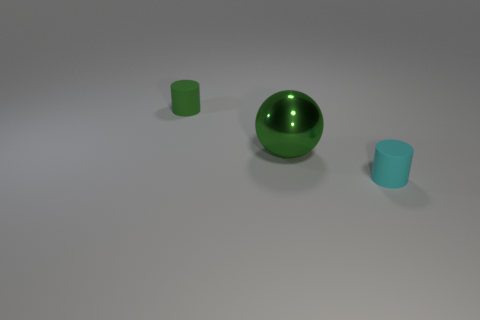Add 3 gray rubber balls. How many objects exist? 6 Subtract all cylinders. How many objects are left? 1 Add 3 green metallic things. How many green metallic things exist? 4 Subtract 0 gray blocks. How many objects are left? 3 Subtract all metallic cylinders. Subtract all cylinders. How many objects are left? 1 Add 2 big metal objects. How many big metal objects are left? 3 